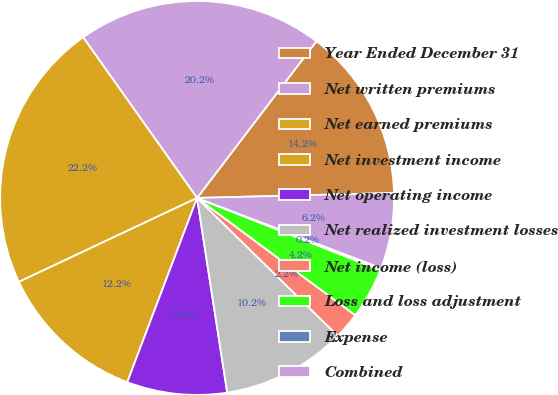Convert chart. <chart><loc_0><loc_0><loc_500><loc_500><pie_chart><fcel>Year Ended December 31<fcel>Net written premiums<fcel>Net earned premiums<fcel>Net investment income<fcel>Net operating income<fcel>Net realized investment losses<fcel>Net income (loss)<fcel>Loss and loss adjustment<fcel>Expense<fcel>Combined<nl><fcel>14.24%<fcel>20.18%<fcel>22.19%<fcel>12.23%<fcel>8.21%<fcel>10.22%<fcel>2.18%<fcel>4.19%<fcel>0.17%<fcel>6.2%<nl></chart> 